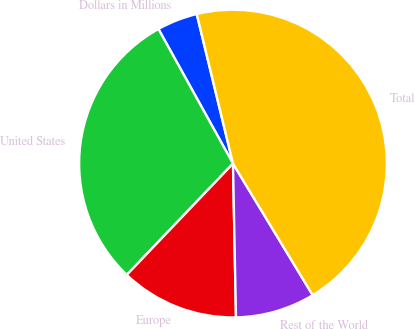Convert chart. <chart><loc_0><loc_0><loc_500><loc_500><pie_chart><fcel>Dollars in Millions<fcel>United States<fcel>Europe<fcel>Rest of the World<fcel>Total<nl><fcel>4.27%<fcel>29.82%<fcel>12.44%<fcel>8.36%<fcel>45.12%<nl></chart> 